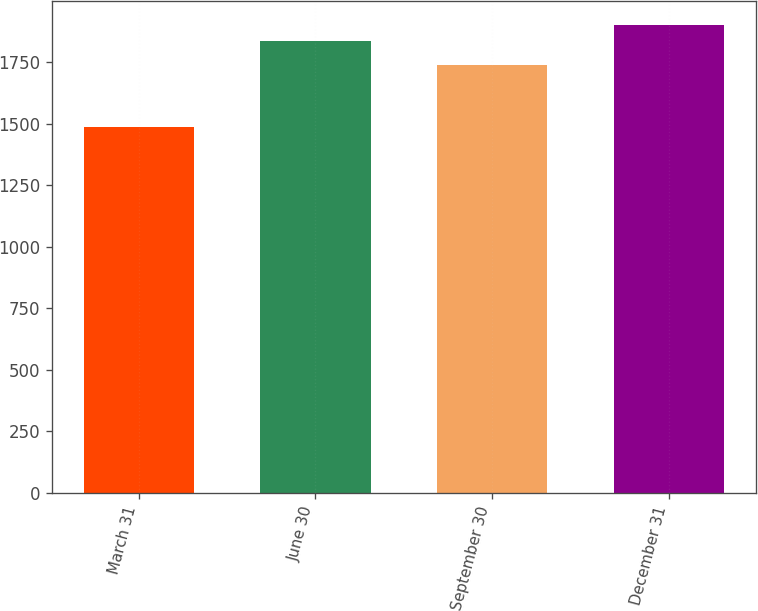Convert chart. <chart><loc_0><loc_0><loc_500><loc_500><bar_chart><fcel>March 31<fcel>June 30<fcel>September 30<fcel>December 31<nl><fcel>1485.2<fcel>1835.7<fcel>1740<fcel>1901.8<nl></chart> 